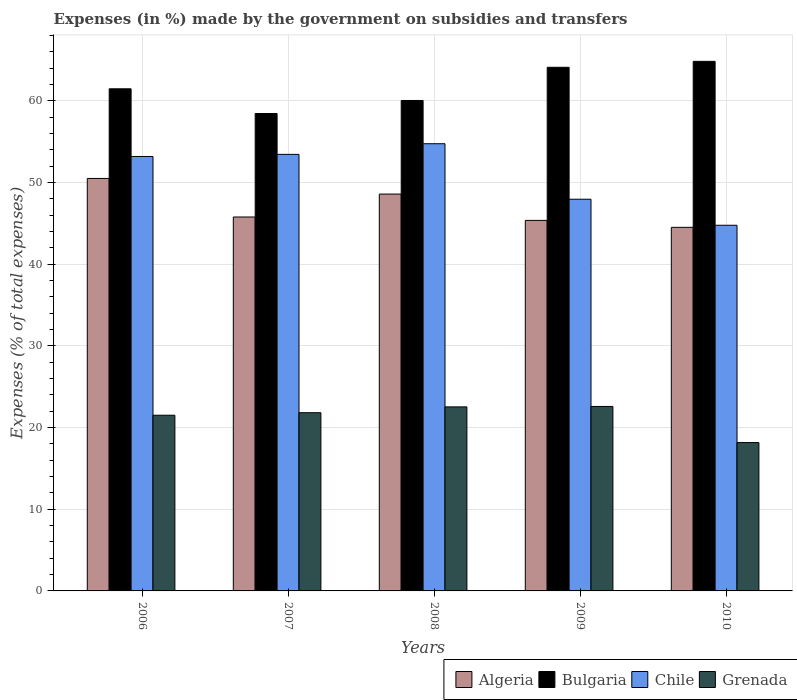How many different coloured bars are there?
Your answer should be compact. 4. Are the number of bars per tick equal to the number of legend labels?
Your answer should be very brief. Yes. How many bars are there on the 3rd tick from the left?
Offer a terse response. 4. How many bars are there on the 3rd tick from the right?
Provide a succinct answer. 4. What is the percentage of expenses made by the government on subsidies and transfers in Algeria in 2006?
Keep it short and to the point. 50.5. Across all years, what is the maximum percentage of expenses made by the government on subsidies and transfers in Grenada?
Make the answer very short. 22.59. Across all years, what is the minimum percentage of expenses made by the government on subsidies and transfers in Bulgaria?
Give a very brief answer. 58.45. What is the total percentage of expenses made by the government on subsidies and transfers in Grenada in the graph?
Provide a succinct answer. 106.62. What is the difference between the percentage of expenses made by the government on subsidies and transfers in Chile in 2006 and that in 2010?
Give a very brief answer. 8.42. What is the difference between the percentage of expenses made by the government on subsidies and transfers in Grenada in 2009 and the percentage of expenses made by the government on subsidies and transfers in Chile in 2006?
Ensure brevity in your answer.  -30.61. What is the average percentage of expenses made by the government on subsidies and transfers in Grenada per year?
Ensure brevity in your answer.  21.32. In the year 2007, what is the difference between the percentage of expenses made by the government on subsidies and transfers in Bulgaria and percentage of expenses made by the government on subsidies and transfers in Chile?
Provide a short and direct response. 5. What is the ratio of the percentage of expenses made by the government on subsidies and transfers in Algeria in 2007 to that in 2008?
Offer a terse response. 0.94. Is the percentage of expenses made by the government on subsidies and transfers in Algeria in 2008 less than that in 2010?
Ensure brevity in your answer.  No. Is the difference between the percentage of expenses made by the government on subsidies and transfers in Bulgaria in 2007 and 2008 greater than the difference between the percentage of expenses made by the government on subsidies and transfers in Chile in 2007 and 2008?
Give a very brief answer. No. What is the difference between the highest and the second highest percentage of expenses made by the government on subsidies and transfers in Algeria?
Give a very brief answer. 1.91. What is the difference between the highest and the lowest percentage of expenses made by the government on subsidies and transfers in Grenada?
Ensure brevity in your answer.  4.42. In how many years, is the percentage of expenses made by the government on subsidies and transfers in Chile greater than the average percentage of expenses made by the government on subsidies and transfers in Chile taken over all years?
Your answer should be compact. 3. Is it the case that in every year, the sum of the percentage of expenses made by the government on subsidies and transfers in Grenada and percentage of expenses made by the government on subsidies and transfers in Bulgaria is greater than the sum of percentage of expenses made by the government on subsidies and transfers in Algeria and percentage of expenses made by the government on subsidies and transfers in Chile?
Ensure brevity in your answer.  No. What does the 4th bar from the left in 2006 represents?
Offer a very short reply. Grenada. What does the 4th bar from the right in 2008 represents?
Offer a very short reply. Algeria. Are the values on the major ticks of Y-axis written in scientific E-notation?
Your response must be concise. No. Does the graph contain grids?
Your answer should be very brief. Yes. Where does the legend appear in the graph?
Ensure brevity in your answer.  Bottom right. How are the legend labels stacked?
Your answer should be compact. Horizontal. What is the title of the graph?
Your response must be concise. Expenses (in %) made by the government on subsidies and transfers. Does "Kosovo" appear as one of the legend labels in the graph?
Give a very brief answer. No. What is the label or title of the Y-axis?
Offer a very short reply. Expenses (% of total expenses). What is the Expenses (% of total expenses) of Algeria in 2006?
Offer a terse response. 50.5. What is the Expenses (% of total expenses) in Bulgaria in 2006?
Your answer should be very brief. 61.48. What is the Expenses (% of total expenses) in Chile in 2006?
Your response must be concise. 53.19. What is the Expenses (% of total expenses) of Grenada in 2006?
Offer a terse response. 21.51. What is the Expenses (% of total expenses) of Algeria in 2007?
Offer a very short reply. 45.78. What is the Expenses (% of total expenses) in Bulgaria in 2007?
Provide a short and direct response. 58.45. What is the Expenses (% of total expenses) of Chile in 2007?
Your response must be concise. 53.45. What is the Expenses (% of total expenses) of Grenada in 2007?
Provide a short and direct response. 21.82. What is the Expenses (% of total expenses) in Algeria in 2008?
Offer a very short reply. 48.59. What is the Expenses (% of total expenses) in Bulgaria in 2008?
Offer a terse response. 60.05. What is the Expenses (% of total expenses) of Chile in 2008?
Your answer should be very brief. 54.76. What is the Expenses (% of total expenses) of Grenada in 2008?
Provide a succinct answer. 22.53. What is the Expenses (% of total expenses) in Algeria in 2009?
Your answer should be very brief. 45.37. What is the Expenses (% of total expenses) of Bulgaria in 2009?
Offer a very short reply. 64.11. What is the Expenses (% of total expenses) of Chile in 2009?
Offer a terse response. 47.96. What is the Expenses (% of total expenses) of Grenada in 2009?
Make the answer very short. 22.59. What is the Expenses (% of total expenses) in Algeria in 2010?
Make the answer very short. 44.52. What is the Expenses (% of total expenses) in Bulgaria in 2010?
Make the answer very short. 64.84. What is the Expenses (% of total expenses) of Chile in 2010?
Your answer should be compact. 44.77. What is the Expenses (% of total expenses) in Grenada in 2010?
Provide a short and direct response. 18.16. Across all years, what is the maximum Expenses (% of total expenses) of Algeria?
Offer a terse response. 50.5. Across all years, what is the maximum Expenses (% of total expenses) of Bulgaria?
Your response must be concise. 64.84. Across all years, what is the maximum Expenses (% of total expenses) in Chile?
Provide a succinct answer. 54.76. Across all years, what is the maximum Expenses (% of total expenses) of Grenada?
Offer a very short reply. 22.59. Across all years, what is the minimum Expenses (% of total expenses) of Algeria?
Give a very brief answer. 44.52. Across all years, what is the minimum Expenses (% of total expenses) of Bulgaria?
Your answer should be compact. 58.45. Across all years, what is the minimum Expenses (% of total expenses) of Chile?
Ensure brevity in your answer.  44.77. Across all years, what is the minimum Expenses (% of total expenses) in Grenada?
Keep it short and to the point. 18.16. What is the total Expenses (% of total expenses) in Algeria in the graph?
Offer a terse response. 234.76. What is the total Expenses (% of total expenses) of Bulgaria in the graph?
Ensure brevity in your answer.  308.94. What is the total Expenses (% of total expenses) of Chile in the graph?
Ensure brevity in your answer.  254.13. What is the total Expenses (% of total expenses) of Grenada in the graph?
Provide a succinct answer. 106.62. What is the difference between the Expenses (% of total expenses) in Algeria in 2006 and that in 2007?
Provide a short and direct response. 4.72. What is the difference between the Expenses (% of total expenses) of Bulgaria in 2006 and that in 2007?
Your answer should be compact. 3.03. What is the difference between the Expenses (% of total expenses) of Chile in 2006 and that in 2007?
Offer a terse response. -0.26. What is the difference between the Expenses (% of total expenses) in Grenada in 2006 and that in 2007?
Offer a terse response. -0.31. What is the difference between the Expenses (% of total expenses) in Algeria in 2006 and that in 2008?
Give a very brief answer. 1.91. What is the difference between the Expenses (% of total expenses) of Bulgaria in 2006 and that in 2008?
Offer a terse response. 1.43. What is the difference between the Expenses (% of total expenses) of Chile in 2006 and that in 2008?
Your response must be concise. -1.56. What is the difference between the Expenses (% of total expenses) of Grenada in 2006 and that in 2008?
Give a very brief answer. -1.02. What is the difference between the Expenses (% of total expenses) in Algeria in 2006 and that in 2009?
Your answer should be compact. 5.14. What is the difference between the Expenses (% of total expenses) of Bulgaria in 2006 and that in 2009?
Provide a short and direct response. -2.63. What is the difference between the Expenses (% of total expenses) of Chile in 2006 and that in 2009?
Provide a short and direct response. 5.23. What is the difference between the Expenses (% of total expenses) in Grenada in 2006 and that in 2009?
Ensure brevity in your answer.  -1.08. What is the difference between the Expenses (% of total expenses) of Algeria in 2006 and that in 2010?
Offer a terse response. 5.99. What is the difference between the Expenses (% of total expenses) of Bulgaria in 2006 and that in 2010?
Ensure brevity in your answer.  -3.36. What is the difference between the Expenses (% of total expenses) in Chile in 2006 and that in 2010?
Offer a terse response. 8.42. What is the difference between the Expenses (% of total expenses) of Grenada in 2006 and that in 2010?
Give a very brief answer. 3.35. What is the difference between the Expenses (% of total expenses) of Algeria in 2007 and that in 2008?
Your response must be concise. -2.81. What is the difference between the Expenses (% of total expenses) of Bulgaria in 2007 and that in 2008?
Your answer should be very brief. -1.6. What is the difference between the Expenses (% of total expenses) in Chile in 2007 and that in 2008?
Make the answer very short. -1.3. What is the difference between the Expenses (% of total expenses) of Grenada in 2007 and that in 2008?
Offer a terse response. -0.71. What is the difference between the Expenses (% of total expenses) in Algeria in 2007 and that in 2009?
Keep it short and to the point. 0.42. What is the difference between the Expenses (% of total expenses) in Bulgaria in 2007 and that in 2009?
Your response must be concise. -5.66. What is the difference between the Expenses (% of total expenses) of Chile in 2007 and that in 2009?
Your answer should be very brief. 5.49. What is the difference between the Expenses (% of total expenses) in Grenada in 2007 and that in 2009?
Provide a succinct answer. -0.77. What is the difference between the Expenses (% of total expenses) in Algeria in 2007 and that in 2010?
Offer a terse response. 1.27. What is the difference between the Expenses (% of total expenses) in Bulgaria in 2007 and that in 2010?
Give a very brief answer. -6.39. What is the difference between the Expenses (% of total expenses) of Chile in 2007 and that in 2010?
Your response must be concise. 8.68. What is the difference between the Expenses (% of total expenses) of Grenada in 2007 and that in 2010?
Provide a succinct answer. 3.66. What is the difference between the Expenses (% of total expenses) in Algeria in 2008 and that in 2009?
Provide a succinct answer. 3.22. What is the difference between the Expenses (% of total expenses) in Bulgaria in 2008 and that in 2009?
Provide a short and direct response. -4.06. What is the difference between the Expenses (% of total expenses) of Chile in 2008 and that in 2009?
Provide a succinct answer. 6.8. What is the difference between the Expenses (% of total expenses) of Grenada in 2008 and that in 2009?
Provide a succinct answer. -0.05. What is the difference between the Expenses (% of total expenses) of Algeria in 2008 and that in 2010?
Offer a very short reply. 4.07. What is the difference between the Expenses (% of total expenses) in Bulgaria in 2008 and that in 2010?
Your response must be concise. -4.79. What is the difference between the Expenses (% of total expenses) in Chile in 2008 and that in 2010?
Your answer should be compact. 9.98. What is the difference between the Expenses (% of total expenses) in Grenada in 2008 and that in 2010?
Ensure brevity in your answer.  4.37. What is the difference between the Expenses (% of total expenses) of Algeria in 2009 and that in 2010?
Ensure brevity in your answer.  0.85. What is the difference between the Expenses (% of total expenses) in Bulgaria in 2009 and that in 2010?
Offer a very short reply. -0.73. What is the difference between the Expenses (% of total expenses) in Chile in 2009 and that in 2010?
Ensure brevity in your answer.  3.19. What is the difference between the Expenses (% of total expenses) of Grenada in 2009 and that in 2010?
Your answer should be compact. 4.42. What is the difference between the Expenses (% of total expenses) of Algeria in 2006 and the Expenses (% of total expenses) of Bulgaria in 2007?
Ensure brevity in your answer.  -7.95. What is the difference between the Expenses (% of total expenses) of Algeria in 2006 and the Expenses (% of total expenses) of Chile in 2007?
Your response must be concise. -2.95. What is the difference between the Expenses (% of total expenses) of Algeria in 2006 and the Expenses (% of total expenses) of Grenada in 2007?
Your answer should be compact. 28.68. What is the difference between the Expenses (% of total expenses) in Bulgaria in 2006 and the Expenses (% of total expenses) in Chile in 2007?
Ensure brevity in your answer.  8.03. What is the difference between the Expenses (% of total expenses) of Bulgaria in 2006 and the Expenses (% of total expenses) of Grenada in 2007?
Keep it short and to the point. 39.66. What is the difference between the Expenses (% of total expenses) in Chile in 2006 and the Expenses (% of total expenses) in Grenada in 2007?
Your answer should be very brief. 31.37. What is the difference between the Expenses (% of total expenses) in Algeria in 2006 and the Expenses (% of total expenses) in Bulgaria in 2008?
Your answer should be very brief. -9.55. What is the difference between the Expenses (% of total expenses) in Algeria in 2006 and the Expenses (% of total expenses) in Chile in 2008?
Offer a very short reply. -4.25. What is the difference between the Expenses (% of total expenses) in Algeria in 2006 and the Expenses (% of total expenses) in Grenada in 2008?
Offer a very short reply. 27.97. What is the difference between the Expenses (% of total expenses) of Bulgaria in 2006 and the Expenses (% of total expenses) of Chile in 2008?
Provide a short and direct response. 6.72. What is the difference between the Expenses (% of total expenses) in Bulgaria in 2006 and the Expenses (% of total expenses) in Grenada in 2008?
Keep it short and to the point. 38.95. What is the difference between the Expenses (% of total expenses) of Chile in 2006 and the Expenses (% of total expenses) of Grenada in 2008?
Provide a succinct answer. 30.66. What is the difference between the Expenses (% of total expenses) of Algeria in 2006 and the Expenses (% of total expenses) of Bulgaria in 2009?
Give a very brief answer. -13.61. What is the difference between the Expenses (% of total expenses) in Algeria in 2006 and the Expenses (% of total expenses) in Chile in 2009?
Provide a short and direct response. 2.55. What is the difference between the Expenses (% of total expenses) of Algeria in 2006 and the Expenses (% of total expenses) of Grenada in 2009?
Make the answer very short. 27.92. What is the difference between the Expenses (% of total expenses) of Bulgaria in 2006 and the Expenses (% of total expenses) of Chile in 2009?
Offer a very short reply. 13.52. What is the difference between the Expenses (% of total expenses) in Bulgaria in 2006 and the Expenses (% of total expenses) in Grenada in 2009?
Offer a terse response. 38.89. What is the difference between the Expenses (% of total expenses) of Chile in 2006 and the Expenses (% of total expenses) of Grenada in 2009?
Ensure brevity in your answer.  30.61. What is the difference between the Expenses (% of total expenses) in Algeria in 2006 and the Expenses (% of total expenses) in Bulgaria in 2010?
Provide a succinct answer. -14.34. What is the difference between the Expenses (% of total expenses) of Algeria in 2006 and the Expenses (% of total expenses) of Chile in 2010?
Give a very brief answer. 5.73. What is the difference between the Expenses (% of total expenses) in Algeria in 2006 and the Expenses (% of total expenses) in Grenada in 2010?
Provide a short and direct response. 32.34. What is the difference between the Expenses (% of total expenses) in Bulgaria in 2006 and the Expenses (% of total expenses) in Chile in 2010?
Give a very brief answer. 16.71. What is the difference between the Expenses (% of total expenses) in Bulgaria in 2006 and the Expenses (% of total expenses) in Grenada in 2010?
Offer a very short reply. 43.32. What is the difference between the Expenses (% of total expenses) of Chile in 2006 and the Expenses (% of total expenses) of Grenada in 2010?
Offer a very short reply. 35.03. What is the difference between the Expenses (% of total expenses) of Algeria in 2007 and the Expenses (% of total expenses) of Bulgaria in 2008?
Your response must be concise. -14.27. What is the difference between the Expenses (% of total expenses) of Algeria in 2007 and the Expenses (% of total expenses) of Chile in 2008?
Provide a short and direct response. -8.97. What is the difference between the Expenses (% of total expenses) of Algeria in 2007 and the Expenses (% of total expenses) of Grenada in 2008?
Offer a terse response. 23.25. What is the difference between the Expenses (% of total expenses) in Bulgaria in 2007 and the Expenses (% of total expenses) in Chile in 2008?
Make the answer very short. 3.7. What is the difference between the Expenses (% of total expenses) in Bulgaria in 2007 and the Expenses (% of total expenses) in Grenada in 2008?
Provide a short and direct response. 35.92. What is the difference between the Expenses (% of total expenses) in Chile in 2007 and the Expenses (% of total expenses) in Grenada in 2008?
Ensure brevity in your answer.  30.92. What is the difference between the Expenses (% of total expenses) of Algeria in 2007 and the Expenses (% of total expenses) of Bulgaria in 2009?
Ensure brevity in your answer.  -18.33. What is the difference between the Expenses (% of total expenses) in Algeria in 2007 and the Expenses (% of total expenses) in Chile in 2009?
Provide a short and direct response. -2.18. What is the difference between the Expenses (% of total expenses) of Algeria in 2007 and the Expenses (% of total expenses) of Grenada in 2009?
Provide a succinct answer. 23.2. What is the difference between the Expenses (% of total expenses) in Bulgaria in 2007 and the Expenses (% of total expenses) in Chile in 2009?
Give a very brief answer. 10.5. What is the difference between the Expenses (% of total expenses) of Bulgaria in 2007 and the Expenses (% of total expenses) of Grenada in 2009?
Your answer should be compact. 35.87. What is the difference between the Expenses (% of total expenses) in Chile in 2007 and the Expenses (% of total expenses) in Grenada in 2009?
Make the answer very short. 30.86. What is the difference between the Expenses (% of total expenses) in Algeria in 2007 and the Expenses (% of total expenses) in Bulgaria in 2010?
Provide a succinct answer. -19.06. What is the difference between the Expenses (% of total expenses) of Algeria in 2007 and the Expenses (% of total expenses) of Grenada in 2010?
Provide a succinct answer. 27.62. What is the difference between the Expenses (% of total expenses) of Bulgaria in 2007 and the Expenses (% of total expenses) of Chile in 2010?
Keep it short and to the point. 13.68. What is the difference between the Expenses (% of total expenses) of Bulgaria in 2007 and the Expenses (% of total expenses) of Grenada in 2010?
Give a very brief answer. 40.29. What is the difference between the Expenses (% of total expenses) in Chile in 2007 and the Expenses (% of total expenses) in Grenada in 2010?
Your response must be concise. 35.29. What is the difference between the Expenses (% of total expenses) of Algeria in 2008 and the Expenses (% of total expenses) of Bulgaria in 2009?
Provide a succinct answer. -15.52. What is the difference between the Expenses (% of total expenses) of Algeria in 2008 and the Expenses (% of total expenses) of Chile in 2009?
Provide a succinct answer. 0.63. What is the difference between the Expenses (% of total expenses) in Algeria in 2008 and the Expenses (% of total expenses) in Grenada in 2009?
Give a very brief answer. 26. What is the difference between the Expenses (% of total expenses) of Bulgaria in 2008 and the Expenses (% of total expenses) of Chile in 2009?
Ensure brevity in your answer.  12.09. What is the difference between the Expenses (% of total expenses) in Bulgaria in 2008 and the Expenses (% of total expenses) in Grenada in 2009?
Provide a succinct answer. 37.46. What is the difference between the Expenses (% of total expenses) in Chile in 2008 and the Expenses (% of total expenses) in Grenada in 2009?
Provide a short and direct response. 32.17. What is the difference between the Expenses (% of total expenses) in Algeria in 2008 and the Expenses (% of total expenses) in Bulgaria in 2010?
Provide a succinct answer. -16.25. What is the difference between the Expenses (% of total expenses) in Algeria in 2008 and the Expenses (% of total expenses) in Chile in 2010?
Your answer should be very brief. 3.82. What is the difference between the Expenses (% of total expenses) of Algeria in 2008 and the Expenses (% of total expenses) of Grenada in 2010?
Offer a terse response. 30.43. What is the difference between the Expenses (% of total expenses) of Bulgaria in 2008 and the Expenses (% of total expenses) of Chile in 2010?
Offer a terse response. 15.28. What is the difference between the Expenses (% of total expenses) of Bulgaria in 2008 and the Expenses (% of total expenses) of Grenada in 2010?
Your response must be concise. 41.89. What is the difference between the Expenses (% of total expenses) in Chile in 2008 and the Expenses (% of total expenses) in Grenada in 2010?
Your response must be concise. 36.59. What is the difference between the Expenses (% of total expenses) of Algeria in 2009 and the Expenses (% of total expenses) of Bulgaria in 2010?
Give a very brief answer. -19.47. What is the difference between the Expenses (% of total expenses) in Algeria in 2009 and the Expenses (% of total expenses) in Chile in 2010?
Keep it short and to the point. 0.6. What is the difference between the Expenses (% of total expenses) in Algeria in 2009 and the Expenses (% of total expenses) in Grenada in 2010?
Offer a very short reply. 27.2. What is the difference between the Expenses (% of total expenses) in Bulgaria in 2009 and the Expenses (% of total expenses) in Chile in 2010?
Ensure brevity in your answer.  19.34. What is the difference between the Expenses (% of total expenses) of Bulgaria in 2009 and the Expenses (% of total expenses) of Grenada in 2010?
Your response must be concise. 45.95. What is the difference between the Expenses (% of total expenses) of Chile in 2009 and the Expenses (% of total expenses) of Grenada in 2010?
Provide a succinct answer. 29.79. What is the average Expenses (% of total expenses) in Algeria per year?
Offer a very short reply. 46.95. What is the average Expenses (% of total expenses) in Bulgaria per year?
Give a very brief answer. 61.79. What is the average Expenses (% of total expenses) of Chile per year?
Provide a short and direct response. 50.83. What is the average Expenses (% of total expenses) of Grenada per year?
Offer a terse response. 21.32. In the year 2006, what is the difference between the Expenses (% of total expenses) in Algeria and Expenses (% of total expenses) in Bulgaria?
Provide a succinct answer. -10.98. In the year 2006, what is the difference between the Expenses (% of total expenses) in Algeria and Expenses (% of total expenses) in Chile?
Your answer should be very brief. -2.69. In the year 2006, what is the difference between the Expenses (% of total expenses) in Algeria and Expenses (% of total expenses) in Grenada?
Your response must be concise. 28.99. In the year 2006, what is the difference between the Expenses (% of total expenses) of Bulgaria and Expenses (% of total expenses) of Chile?
Keep it short and to the point. 8.29. In the year 2006, what is the difference between the Expenses (% of total expenses) in Bulgaria and Expenses (% of total expenses) in Grenada?
Offer a terse response. 39.97. In the year 2006, what is the difference between the Expenses (% of total expenses) of Chile and Expenses (% of total expenses) of Grenada?
Your answer should be compact. 31.68. In the year 2007, what is the difference between the Expenses (% of total expenses) of Algeria and Expenses (% of total expenses) of Bulgaria?
Provide a short and direct response. -12.67. In the year 2007, what is the difference between the Expenses (% of total expenses) in Algeria and Expenses (% of total expenses) in Chile?
Make the answer very short. -7.67. In the year 2007, what is the difference between the Expenses (% of total expenses) in Algeria and Expenses (% of total expenses) in Grenada?
Offer a terse response. 23.96. In the year 2007, what is the difference between the Expenses (% of total expenses) of Bulgaria and Expenses (% of total expenses) of Chile?
Keep it short and to the point. 5. In the year 2007, what is the difference between the Expenses (% of total expenses) in Bulgaria and Expenses (% of total expenses) in Grenada?
Your response must be concise. 36.63. In the year 2007, what is the difference between the Expenses (% of total expenses) of Chile and Expenses (% of total expenses) of Grenada?
Your response must be concise. 31.63. In the year 2008, what is the difference between the Expenses (% of total expenses) of Algeria and Expenses (% of total expenses) of Bulgaria?
Give a very brief answer. -11.46. In the year 2008, what is the difference between the Expenses (% of total expenses) of Algeria and Expenses (% of total expenses) of Chile?
Offer a terse response. -6.17. In the year 2008, what is the difference between the Expenses (% of total expenses) in Algeria and Expenses (% of total expenses) in Grenada?
Provide a short and direct response. 26.06. In the year 2008, what is the difference between the Expenses (% of total expenses) in Bulgaria and Expenses (% of total expenses) in Chile?
Offer a very short reply. 5.3. In the year 2008, what is the difference between the Expenses (% of total expenses) in Bulgaria and Expenses (% of total expenses) in Grenada?
Ensure brevity in your answer.  37.52. In the year 2008, what is the difference between the Expenses (% of total expenses) of Chile and Expenses (% of total expenses) of Grenada?
Make the answer very short. 32.22. In the year 2009, what is the difference between the Expenses (% of total expenses) of Algeria and Expenses (% of total expenses) of Bulgaria?
Make the answer very short. -18.75. In the year 2009, what is the difference between the Expenses (% of total expenses) in Algeria and Expenses (% of total expenses) in Chile?
Provide a succinct answer. -2.59. In the year 2009, what is the difference between the Expenses (% of total expenses) of Algeria and Expenses (% of total expenses) of Grenada?
Ensure brevity in your answer.  22.78. In the year 2009, what is the difference between the Expenses (% of total expenses) in Bulgaria and Expenses (% of total expenses) in Chile?
Provide a short and direct response. 16.15. In the year 2009, what is the difference between the Expenses (% of total expenses) in Bulgaria and Expenses (% of total expenses) in Grenada?
Make the answer very short. 41.53. In the year 2009, what is the difference between the Expenses (% of total expenses) of Chile and Expenses (% of total expenses) of Grenada?
Ensure brevity in your answer.  25.37. In the year 2010, what is the difference between the Expenses (% of total expenses) in Algeria and Expenses (% of total expenses) in Bulgaria?
Offer a terse response. -20.32. In the year 2010, what is the difference between the Expenses (% of total expenses) in Algeria and Expenses (% of total expenses) in Chile?
Your answer should be compact. -0.25. In the year 2010, what is the difference between the Expenses (% of total expenses) in Algeria and Expenses (% of total expenses) in Grenada?
Your response must be concise. 26.35. In the year 2010, what is the difference between the Expenses (% of total expenses) in Bulgaria and Expenses (% of total expenses) in Chile?
Give a very brief answer. 20.07. In the year 2010, what is the difference between the Expenses (% of total expenses) of Bulgaria and Expenses (% of total expenses) of Grenada?
Ensure brevity in your answer.  46.68. In the year 2010, what is the difference between the Expenses (% of total expenses) of Chile and Expenses (% of total expenses) of Grenada?
Your answer should be very brief. 26.61. What is the ratio of the Expenses (% of total expenses) in Algeria in 2006 to that in 2007?
Keep it short and to the point. 1.1. What is the ratio of the Expenses (% of total expenses) of Bulgaria in 2006 to that in 2007?
Make the answer very short. 1.05. What is the ratio of the Expenses (% of total expenses) of Grenada in 2006 to that in 2007?
Your response must be concise. 0.99. What is the ratio of the Expenses (% of total expenses) in Algeria in 2006 to that in 2008?
Offer a terse response. 1.04. What is the ratio of the Expenses (% of total expenses) in Bulgaria in 2006 to that in 2008?
Make the answer very short. 1.02. What is the ratio of the Expenses (% of total expenses) of Chile in 2006 to that in 2008?
Provide a succinct answer. 0.97. What is the ratio of the Expenses (% of total expenses) of Grenada in 2006 to that in 2008?
Make the answer very short. 0.95. What is the ratio of the Expenses (% of total expenses) in Algeria in 2006 to that in 2009?
Keep it short and to the point. 1.11. What is the ratio of the Expenses (% of total expenses) in Bulgaria in 2006 to that in 2009?
Provide a succinct answer. 0.96. What is the ratio of the Expenses (% of total expenses) in Chile in 2006 to that in 2009?
Ensure brevity in your answer.  1.11. What is the ratio of the Expenses (% of total expenses) in Algeria in 2006 to that in 2010?
Your answer should be very brief. 1.13. What is the ratio of the Expenses (% of total expenses) of Bulgaria in 2006 to that in 2010?
Your answer should be very brief. 0.95. What is the ratio of the Expenses (% of total expenses) in Chile in 2006 to that in 2010?
Provide a short and direct response. 1.19. What is the ratio of the Expenses (% of total expenses) of Grenada in 2006 to that in 2010?
Offer a very short reply. 1.18. What is the ratio of the Expenses (% of total expenses) of Algeria in 2007 to that in 2008?
Your answer should be compact. 0.94. What is the ratio of the Expenses (% of total expenses) of Bulgaria in 2007 to that in 2008?
Offer a very short reply. 0.97. What is the ratio of the Expenses (% of total expenses) in Chile in 2007 to that in 2008?
Keep it short and to the point. 0.98. What is the ratio of the Expenses (% of total expenses) of Grenada in 2007 to that in 2008?
Give a very brief answer. 0.97. What is the ratio of the Expenses (% of total expenses) of Algeria in 2007 to that in 2009?
Give a very brief answer. 1.01. What is the ratio of the Expenses (% of total expenses) of Bulgaria in 2007 to that in 2009?
Your answer should be very brief. 0.91. What is the ratio of the Expenses (% of total expenses) of Chile in 2007 to that in 2009?
Offer a very short reply. 1.11. What is the ratio of the Expenses (% of total expenses) of Grenada in 2007 to that in 2009?
Provide a succinct answer. 0.97. What is the ratio of the Expenses (% of total expenses) of Algeria in 2007 to that in 2010?
Your answer should be compact. 1.03. What is the ratio of the Expenses (% of total expenses) of Bulgaria in 2007 to that in 2010?
Keep it short and to the point. 0.9. What is the ratio of the Expenses (% of total expenses) in Chile in 2007 to that in 2010?
Provide a succinct answer. 1.19. What is the ratio of the Expenses (% of total expenses) in Grenada in 2007 to that in 2010?
Ensure brevity in your answer.  1.2. What is the ratio of the Expenses (% of total expenses) of Algeria in 2008 to that in 2009?
Your answer should be very brief. 1.07. What is the ratio of the Expenses (% of total expenses) of Bulgaria in 2008 to that in 2009?
Offer a terse response. 0.94. What is the ratio of the Expenses (% of total expenses) of Chile in 2008 to that in 2009?
Your response must be concise. 1.14. What is the ratio of the Expenses (% of total expenses) of Algeria in 2008 to that in 2010?
Ensure brevity in your answer.  1.09. What is the ratio of the Expenses (% of total expenses) of Bulgaria in 2008 to that in 2010?
Your answer should be very brief. 0.93. What is the ratio of the Expenses (% of total expenses) in Chile in 2008 to that in 2010?
Your answer should be compact. 1.22. What is the ratio of the Expenses (% of total expenses) of Grenada in 2008 to that in 2010?
Make the answer very short. 1.24. What is the ratio of the Expenses (% of total expenses) of Algeria in 2009 to that in 2010?
Ensure brevity in your answer.  1.02. What is the ratio of the Expenses (% of total expenses) of Bulgaria in 2009 to that in 2010?
Your answer should be compact. 0.99. What is the ratio of the Expenses (% of total expenses) in Chile in 2009 to that in 2010?
Keep it short and to the point. 1.07. What is the ratio of the Expenses (% of total expenses) of Grenada in 2009 to that in 2010?
Offer a very short reply. 1.24. What is the difference between the highest and the second highest Expenses (% of total expenses) in Algeria?
Your answer should be compact. 1.91. What is the difference between the highest and the second highest Expenses (% of total expenses) in Bulgaria?
Make the answer very short. 0.73. What is the difference between the highest and the second highest Expenses (% of total expenses) in Chile?
Provide a succinct answer. 1.3. What is the difference between the highest and the second highest Expenses (% of total expenses) of Grenada?
Provide a succinct answer. 0.05. What is the difference between the highest and the lowest Expenses (% of total expenses) of Algeria?
Provide a short and direct response. 5.99. What is the difference between the highest and the lowest Expenses (% of total expenses) of Bulgaria?
Your answer should be compact. 6.39. What is the difference between the highest and the lowest Expenses (% of total expenses) in Chile?
Ensure brevity in your answer.  9.98. What is the difference between the highest and the lowest Expenses (% of total expenses) of Grenada?
Make the answer very short. 4.42. 